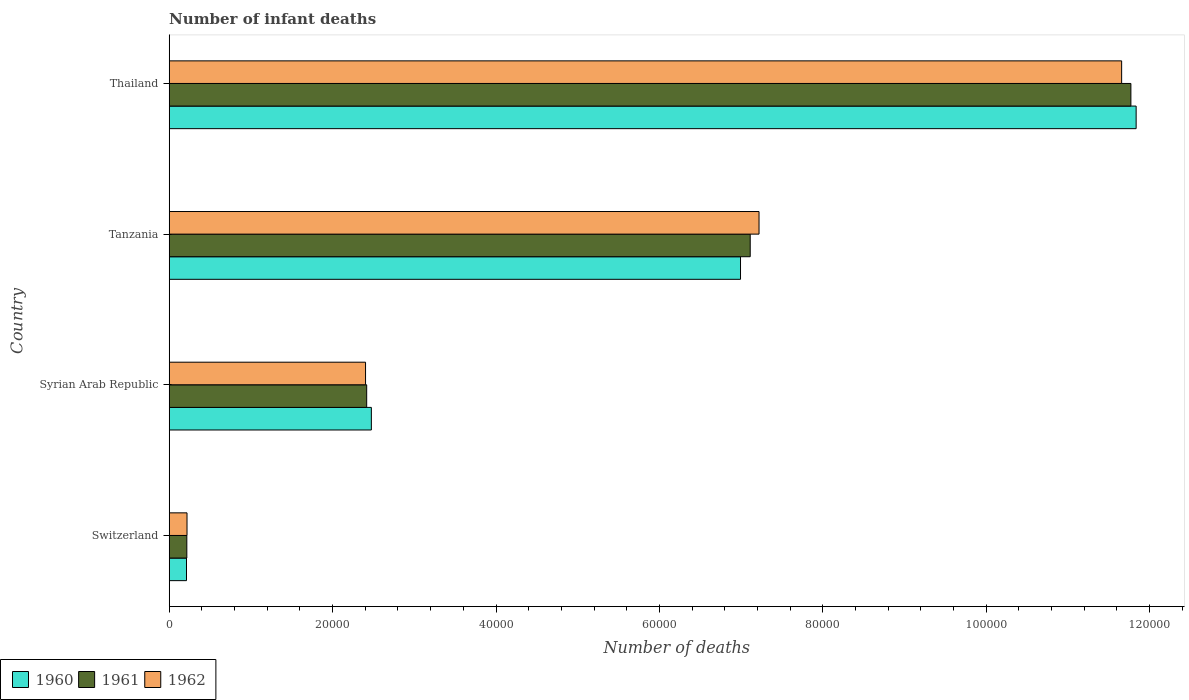How many different coloured bars are there?
Provide a short and direct response. 3. How many bars are there on the 2nd tick from the bottom?
Your answer should be very brief. 3. What is the label of the 2nd group of bars from the top?
Your answer should be very brief. Tanzania. What is the number of infant deaths in 1960 in Switzerland?
Your answer should be compact. 2116. Across all countries, what is the maximum number of infant deaths in 1961?
Make the answer very short. 1.18e+05. Across all countries, what is the minimum number of infant deaths in 1960?
Provide a short and direct response. 2116. In which country was the number of infant deaths in 1962 maximum?
Provide a succinct answer. Thailand. In which country was the number of infant deaths in 1961 minimum?
Ensure brevity in your answer.  Switzerland. What is the total number of infant deaths in 1962 in the graph?
Provide a short and direct response. 2.15e+05. What is the difference between the number of infant deaths in 1961 in Switzerland and that in Syrian Arab Republic?
Make the answer very short. -2.20e+04. What is the difference between the number of infant deaths in 1962 in Syrian Arab Republic and the number of infant deaths in 1960 in Switzerland?
Provide a succinct answer. 2.19e+04. What is the average number of infant deaths in 1961 per country?
Offer a very short reply. 5.38e+04. What is the difference between the number of infant deaths in 1961 and number of infant deaths in 1960 in Tanzania?
Your answer should be very brief. 1186. In how many countries, is the number of infant deaths in 1961 greater than 28000 ?
Make the answer very short. 2. What is the ratio of the number of infant deaths in 1961 in Syrian Arab Republic to that in Thailand?
Keep it short and to the point. 0.21. Is the number of infant deaths in 1960 in Switzerland less than that in Syrian Arab Republic?
Your answer should be very brief. Yes. What is the difference between the highest and the second highest number of infant deaths in 1960?
Make the answer very short. 4.84e+04. What is the difference between the highest and the lowest number of infant deaths in 1960?
Your answer should be compact. 1.16e+05. What does the 2nd bar from the top in Tanzania represents?
Offer a very short reply. 1961. What does the 1st bar from the bottom in Tanzania represents?
Provide a succinct answer. 1960. How many countries are there in the graph?
Offer a very short reply. 4. Are the values on the major ticks of X-axis written in scientific E-notation?
Give a very brief answer. No. Where does the legend appear in the graph?
Offer a very short reply. Bottom left. What is the title of the graph?
Your answer should be compact. Number of infant deaths. Does "2003" appear as one of the legend labels in the graph?
Your answer should be very brief. No. What is the label or title of the X-axis?
Keep it short and to the point. Number of deaths. What is the Number of deaths of 1960 in Switzerland?
Make the answer very short. 2116. What is the Number of deaths in 1961 in Switzerland?
Ensure brevity in your answer.  2157. What is the Number of deaths in 1962 in Switzerland?
Offer a very short reply. 2179. What is the Number of deaths in 1960 in Syrian Arab Republic?
Offer a terse response. 2.47e+04. What is the Number of deaths of 1961 in Syrian Arab Republic?
Your answer should be compact. 2.42e+04. What is the Number of deaths of 1962 in Syrian Arab Republic?
Ensure brevity in your answer.  2.40e+04. What is the Number of deaths in 1960 in Tanzania?
Keep it short and to the point. 6.99e+04. What is the Number of deaths in 1961 in Tanzania?
Give a very brief answer. 7.11e+04. What is the Number of deaths of 1962 in Tanzania?
Give a very brief answer. 7.22e+04. What is the Number of deaths of 1960 in Thailand?
Make the answer very short. 1.18e+05. What is the Number of deaths of 1961 in Thailand?
Your answer should be compact. 1.18e+05. What is the Number of deaths of 1962 in Thailand?
Ensure brevity in your answer.  1.17e+05. Across all countries, what is the maximum Number of deaths in 1960?
Give a very brief answer. 1.18e+05. Across all countries, what is the maximum Number of deaths of 1961?
Offer a terse response. 1.18e+05. Across all countries, what is the maximum Number of deaths of 1962?
Your response must be concise. 1.17e+05. Across all countries, what is the minimum Number of deaths of 1960?
Provide a short and direct response. 2116. Across all countries, what is the minimum Number of deaths in 1961?
Keep it short and to the point. 2157. Across all countries, what is the minimum Number of deaths of 1962?
Your answer should be very brief. 2179. What is the total Number of deaths in 1960 in the graph?
Your answer should be compact. 2.15e+05. What is the total Number of deaths in 1961 in the graph?
Ensure brevity in your answer.  2.15e+05. What is the total Number of deaths of 1962 in the graph?
Provide a short and direct response. 2.15e+05. What is the difference between the Number of deaths of 1960 in Switzerland and that in Syrian Arab Republic?
Keep it short and to the point. -2.26e+04. What is the difference between the Number of deaths of 1961 in Switzerland and that in Syrian Arab Republic?
Provide a succinct answer. -2.20e+04. What is the difference between the Number of deaths of 1962 in Switzerland and that in Syrian Arab Republic?
Give a very brief answer. -2.19e+04. What is the difference between the Number of deaths in 1960 in Switzerland and that in Tanzania?
Give a very brief answer. -6.78e+04. What is the difference between the Number of deaths of 1961 in Switzerland and that in Tanzania?
Ensure brevity in your answer.  -6.90e+04. What is the difference between the Number of deaths in 1962 in Switzerland and that in Tanzania?
Your answer should be compact. -7.00e+04. What is the difference between the Number of deaths in 1960 in Switzerland and that in Thailand?
Provide a succinct answer. -1.16e+05. What is the difference between the Number of deaths of 1961 in Switzerland and that in Thailand?
Give a very brief answer. -1.16e+05. What is the difference between the Number of deaths of 1962 in Switzerland and that in Thailand?
Keep it short and to the point. -1.14e+05. What is the difference between the Number of deaths of 1960 in Syrian Arab Republic and that in Tanzania?
Your answer should be very brief. -4.52e+04. What is the difference between the Number of deaths in 1961 in Syrian Arab Republic and that in Tanzania?
Keep it short and to the point. -4.69e+04. What is the difference between the Number of deaths of 1962 in Syrian Arab Republic and that in Tanzania?
Provide a succinct answer. -4.82e+04. What is the difference between the Number of deaths of 1960 in Syrian Arab Republic and that in Thailand?
Provide a succinct answer. -9.36e+04. What is the difference between the Number of deaths in 1961 in Syrian Arab Republic and that in Thailand?
Your answer should be compact. -9.35e+04. What is the difference between the Number of deaths in 1962 in Syrian Arab Republic and that in Thailand?
Provide a short and direct response. -9.25e+04. What is the difference between the Number of deaths in 1960 in Tanzania and that in Thailand?
Give a very brief answer. -4.84e+04. What is the difference between the Number of deaths in 1961 in Tanzania and that in Thailand?
Your answer should be very brief. -4.66e+04. What is the difference between the Number of deaths in 1962 in Tanzania and that in Thailand?
Offer a very short reply. -4.44e+04. What is the difference between the Number of deaths of 1960 in Switzerland and the Number of deaths of 1961 in Syrian Arab Republic?
Offer a very short reply. -2.21e+04. What is the difference between the Number of deaths in 1960 in Switzerland and the Number of deaths in 1962 in Syrian Arab Republic?
Offer a very short reply. -2.19e+04. What is the difference between the Number of deaths of 1961 in Switzerland and the Number of deaths of 1962 in Syrian Arab Republic?
Provide a short and direct response. -2.19e+04. What is the difference between the Number of deaths in 1960 in Switzerland and the Number of deaths in 1961 in Tanzania?
Keep it short and to the point. -6.90e+04. What is the difference between the Number of deaths in 1960 in Switzerland and the Number of deaths in 1962 in Tanzania?
Offer a very short reply. -7.01e+04. What is the difference between the Number of deaths in 1961 in Switzerland and the Number of deaths in 1962 in Tanzania?
Provide a succinct answer. -7.00e+04. What is the difference between the Number of deaths of 1960 in Switzerland and the Number of deaths of 1961 in Thailand?
Provide a succinct answer. -1.16e+05. What is the difference between the Number of deaths in 1960 in Switzerland and the Number of deaths in 1962 in Thailand?
Provide a succinct answer. -1.14e+05. What is the difference between the Number of deaths of 1961 in Switzerland and the Number of deaths of 1962 in Thailand?
Ensure brevity in your answer.  -1.14e+05. What is the difference between the Number of deaths in 1960 in Syrian Arab Republic and the Number of deaths in 1961 in Tanzania?
Provide a succinct answer. -4.64e+04. What is the difference between the Number of deaths in 1960 in Syrian Arab Republic and the Number of deaths in 1962 in Tanzania?
Give a very brief answer. -4.74e+04. What is the difference between the Number of deaths in 1961 in Syrian Arab Republic and the Number of deaths in 1962 in Tanzania?
Give a very brief answer. -4.80e+04. What is the difference between the Number of deaths of 1960 in Syrian Arab Republic and the Number of deaths of 1961 in Thailand?
Ensure brevity in your answer.  -9.30e+04. What is the difference between the Number of deaths in 1960 in Syrian Arab Republic and the Number of deaths in 1962 in Thailand?
Your response must be concise. -9.18e+04. What is the difference between the Number of deaths of 1961 in Syrian Arab Republic and the Number of deaths of 1962 in Thailand?
Offer a very short reply. -9.24e+04. What is the difference between the Number of deaths in 1960 in Tanzania and the Number of deaths in 1961 in Thailand?
Provide a succinct answer. -4.78e+04. What is the difference between the Number of deaths in 1960 in Tanzania and the Number of deaths in 1962 in Thailand?
Your response must be concise. -4.66e+04. What is the difference between the Number of deaths in 1961 in Tanzania and the Number of deaths in 1962 in Thailand?
Keep it short and to the point. -4.55e+04. What is the average Number of deaths in 1960 per country?
Ensure brevity in your answer.  5.38e+04. What is the average Number of deaths of 1961 per country?
Make the answer very short. 5.38e+04. What is the average Number of deaths in 1962 per country?
Your answer should be very brief. 5.37e+04. What is the difference between the Number of deaths in 1960 and Number of deaths in 1961 in Switzerland?
Your answer should be compact. -41. What is the difference between the Number of deaths of 1960 and Number of deaths of 1962 in Switzerland?
Offer a very short reply. -63. What is the difference between the Number of deaths in 1961 and Number of deaths in 1962 in Switzerland?
Your answer should be very brief. -22. What is the difference between the Number of deaths of 1960 and Number of deaths of 1961 in Syrian Arab Republic?
Offer a terse response. 572. What is the difference between the Number of deaths of 1960 and Number of deaths of 1962 in Syrian Arab Republic?
Offer a terse response. 711. What is the difference between the Number of deaths of 1961 and Number of deaths of 1962 in Syrian Arab Republic?
Make the answer very short. 139. What is the difference between the Number of deaths in 1960 and Number of deaths in 1961 in Tanzania?
Offer a very short reply. -1186. What is the difference between the Number of deaths in 1960 and Number of deaths in 1962 in Tanzania?
Offer a very short reply. -2266. What is the difference between the Number of deaths of 1961 and Number of deaths of 1962 in Tanzania?
Ensure brevity in your answer.  -1080. What is the difference between the Number of deaths in 1960 and Number of deaths in 1961 in Thailand?
Make the answer very short. 643. What is the difference between the Number of deaths in 1960 and Number of deaths in 1962 in Thailand?
Give a very brief answer. 1775. What is the difference between the Number of deaths in 1961 and Number of deaths in 1962 in Thailand?
Your response must be concise. 1132. What is the ratio of the Number of deaths of 1960 in Switzerland to that in Syrian Arab Republic?
Offer a very short reply. 0.09. What is the ratio of the Number of deaths in 1961 in Switzerland to that in Syrian Arab Republic?
Provide a short and direct response. 0.09. What is the ratio of the Number of deaths of 1962 in Switzerland to that in Syrian Arab Republic?
Provide a short and direct response. 0.09. What is the ratio of the Number of deaths in 1960 in Switzerland to that in Tanzania?
Offer a very short reply. 0.03. What is the ratio of the Number of deaths of 1961 in Switzerland to that in Tanzania?
Offer a terse response. 0.03. What is the ratio of the Number of deaths in 1962 in Switzerland to that in Tanzania?
Your answer should be very brief. 0.03. What is the ratio of the Number of deaths of 1960 in Switzerland to that in Thailand?
Ensure brevity in your answer.  0.02. What is the ratio of the Number of deaths of 1961 in Switzerland to that in Thailand?
Your answer should be compact. 0.02. What is the ratio of the Number of deaths in 1962 in Switzerland to that in Thailand?
Your answer should be very brief. 0.02. What is the ratio of the Number of deaths of 1960 in Syrian Arab Republic to that in Tanzania?
Provide a succinct answer. 0.35. What is the ratio of the Number of deaths of 1961 in Syrian Arab Republic to that in Tanzania?
Give a very brief answer. 0.34. What is the ratio of the Number of deaths of 1962 in Syrian Arab Republic to that in Tanzania?
Give a very brief answer. 0.33. What is the ratio of the Number of deaths in 1960 in Syrian Arab Republic to that in Thailand?
Make the answer very short. 0.21. What is the ratio of the Number of deaths in 1961 in Syrian Arab Republic to that in Thailand?
Your response must be concise. 0.21. What is the ratio of the Number of deaths in 1962 in Syrian Arab Republic to that in Thailand?
Make the answer very short. 0.21. What is the ratio of the Number of deaths of 1960 in Tanzania to that in Thailand?
Provide a short and direct response. 0.59. What is the ratio of the Number of deaths of 1961 in Tanzania to that in Thailand?
Keep it short and to the point. 0.6. What is the ratio of the Number of deaths in 1962 in Tanzania to that in Thailand?
Make the answer very short. 0.62. What is the difference between the highest and the second highest Number of deaths of 1960?
Offer a very short reply. 4.84e+04. What is the difference between the highest and the second highest Number of deaths of 1961?
Provide a succinct answer. 4.66e+04. What is the difference between the highest and the second highest Number of deaths in 1962?
Offer a terse response. 4.44e+04. What is the difference between the highest and the lowest Number of deaths of 1960?
Give a very brief answer. 1.16e+05. What is the difference between the highest and the lowest Number of deaths of 1961?
Offer a very short reply. 1.16e+05. What is the difference between the highest and the lowest Number of deaths of 1962?
Ensure brevity in your answer.  1.14e+05. 